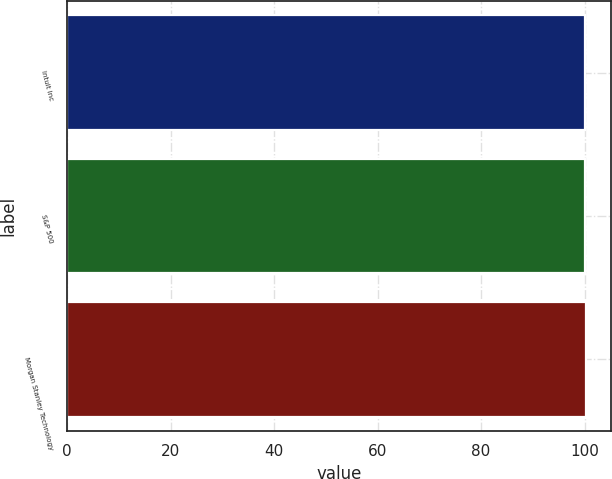<chart> <loc_0><loc_0><loc_500><loc_500><bar_chart><fcel>Intuit Inc<fcel>S&P 500<fcel>Morgan Stanley Technology<nl><fcel>100<fcel>100.1<fcel>100.2<nl></chart> 